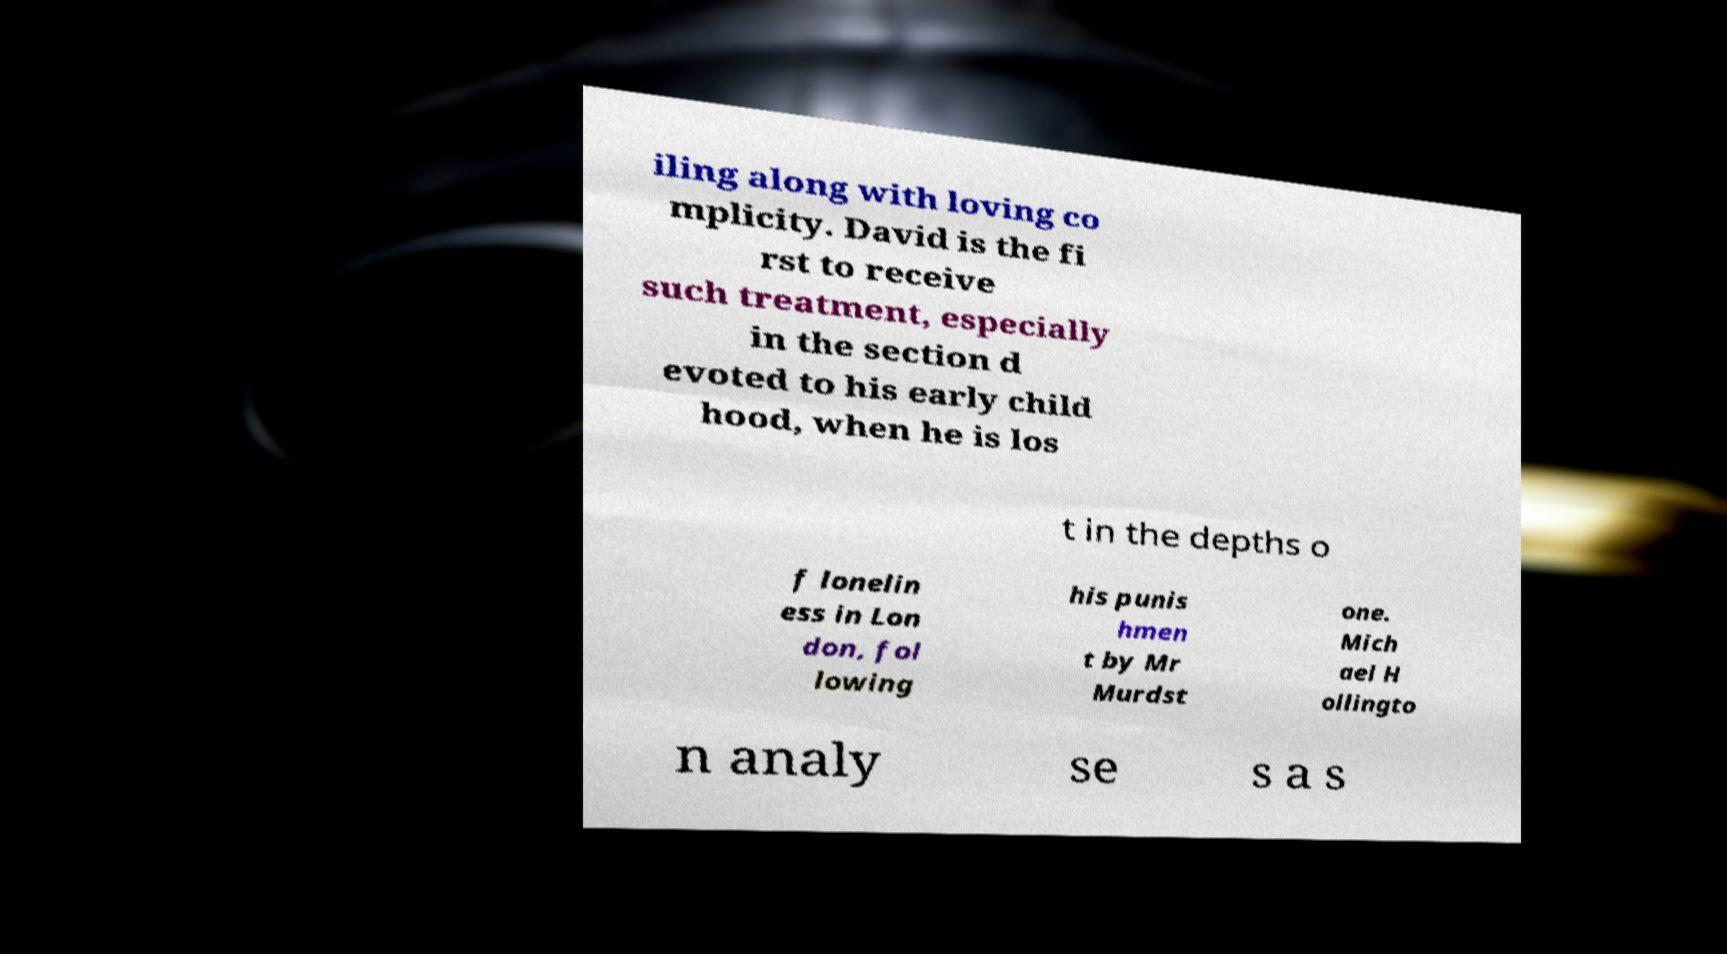What messages or text are displayed in this image? I need them in a readable, typed format. iling along with loving co mplicity. David is the fi rst to receive such treatment, especially in the section d evoted to his early child hood, when he is los t in the depths o f lonelin ess in Lon don, fol lowing his punis hmen t by Mr Murdst one. Mich ael H ollingto n analy se s a s 